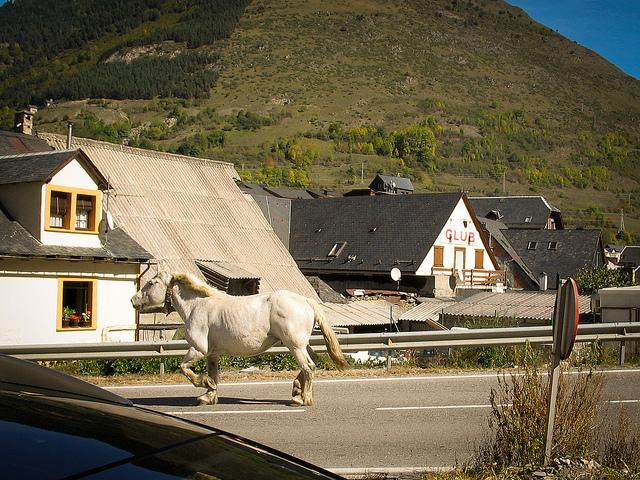Why are the roofs at street level? street below 